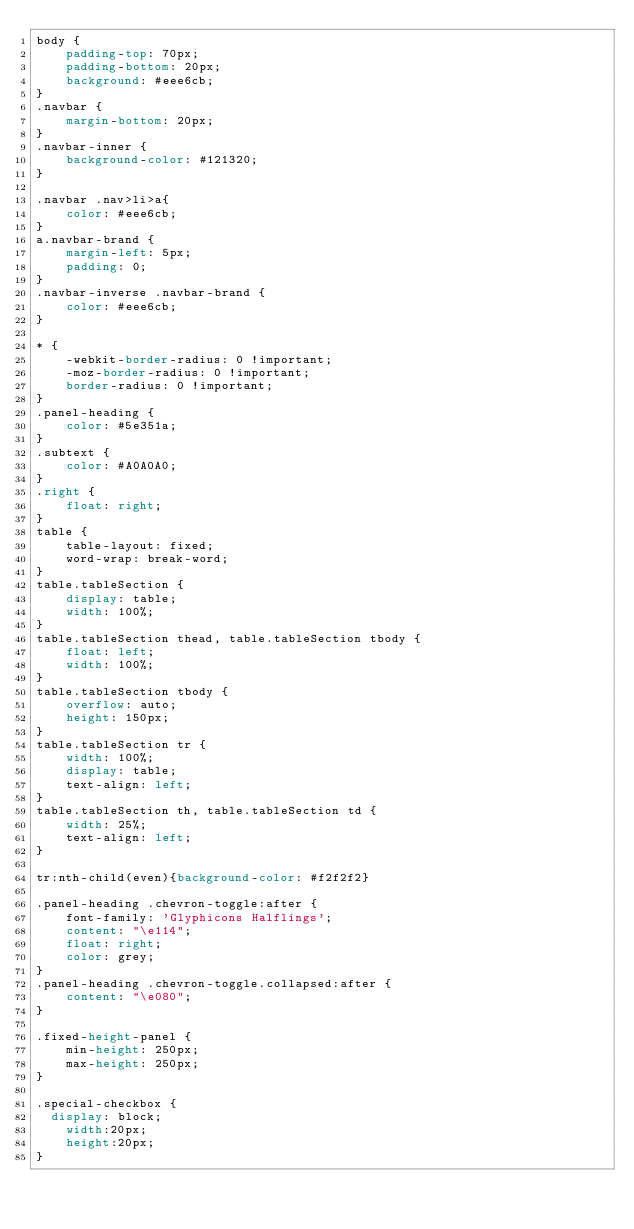<code> <loc_0><loc_0><loc_500><loc_500><_CSS_>body {
    padding-top: 70px;
    padding-bottom: 20px;
    background: #eee6cb;
}
.navbar {
    margin-bottom: 20px;
}
.navbar-inner {
    background-color: #121320;
}

.navbar .nav>li>a{
    color: #eee6cb;
}
a.navbar-brand {
    margin-left: 5px;
    padding: 0;
}
.navbar-inverse .navbar-brand {
    color: #eee6cb;
}

* {
    -webkit-border-radius: 0 !important;
    -moz-border-radius: 0 !important;
    border-radius: 0 !important;
}
.panel-heading {
    color: #5e351a;
}
.subtext {
    color: #A0A0A0;
}
.right {
    float: right;
}
table {
    table-layout: fixed;
    word-wrap: break-word;
}
table.tableSection {
    display: table;
    width: 100%;
}
table.tableSection thead, table.tableSection tbody {
    float: left;
    width: 100%;
}
table.tableSection tbody {
    overflow: auto;
    height: 150px;
}
table.tableSection tr {
    width: 100%;
    display: table;
    text-align: left;
}
table.tableSection th, table.tableSection td {
    width: 25%;
    text-align: left;
}

tr:nth-child(even){background-color: #f2f2f2}

.panel-heading .chevron-toggle:after {
    font-family: 'Glyphicons Halflings';
    content: "\e114";
    float: right;
    color: grey;
}
.panel-heading .chevron-toggle.collapsed:after {
    content: "\e080";
}

.fixed-height-panel {
    min-height: 250px;
    max-height: 250px;
}

.special-checkbox {
  display: block;
    width:20px;
    height:20px;
}
</code> 